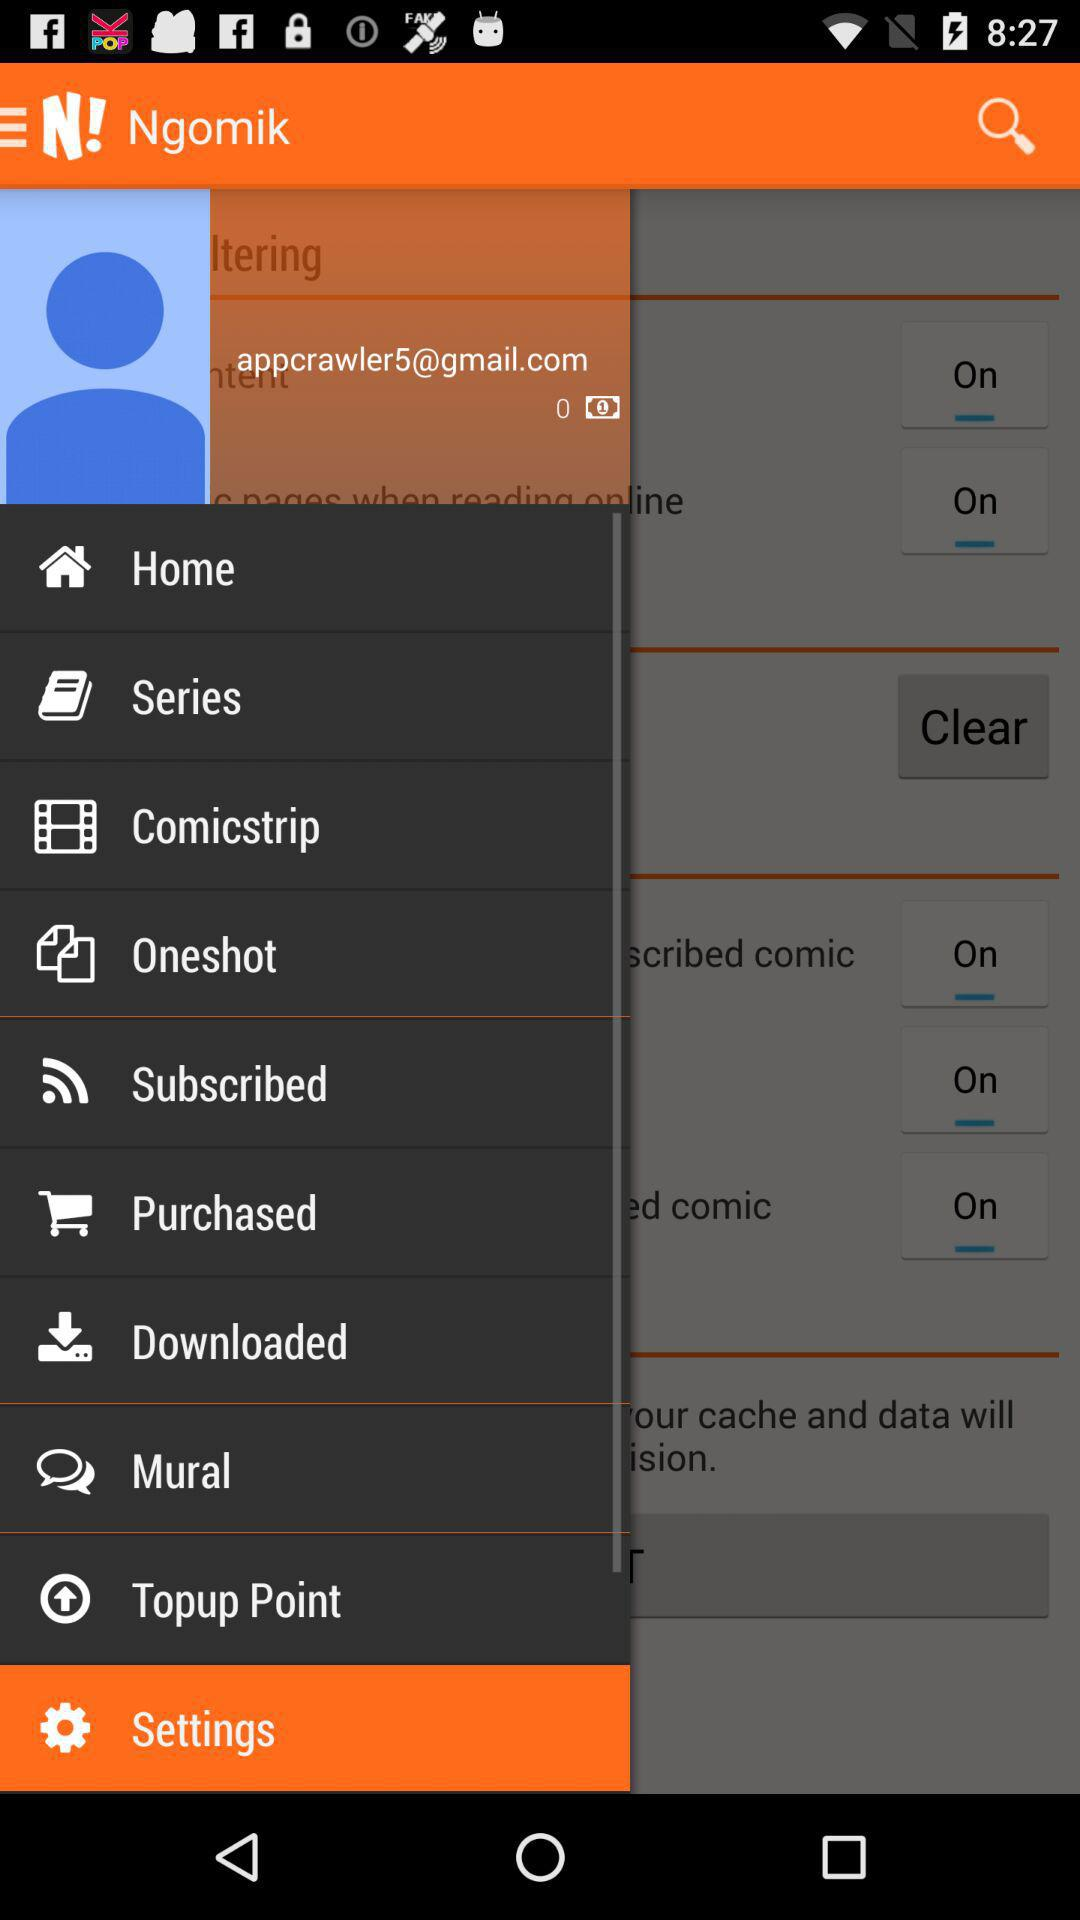What option is currently selected? The selected option is "Settings". 